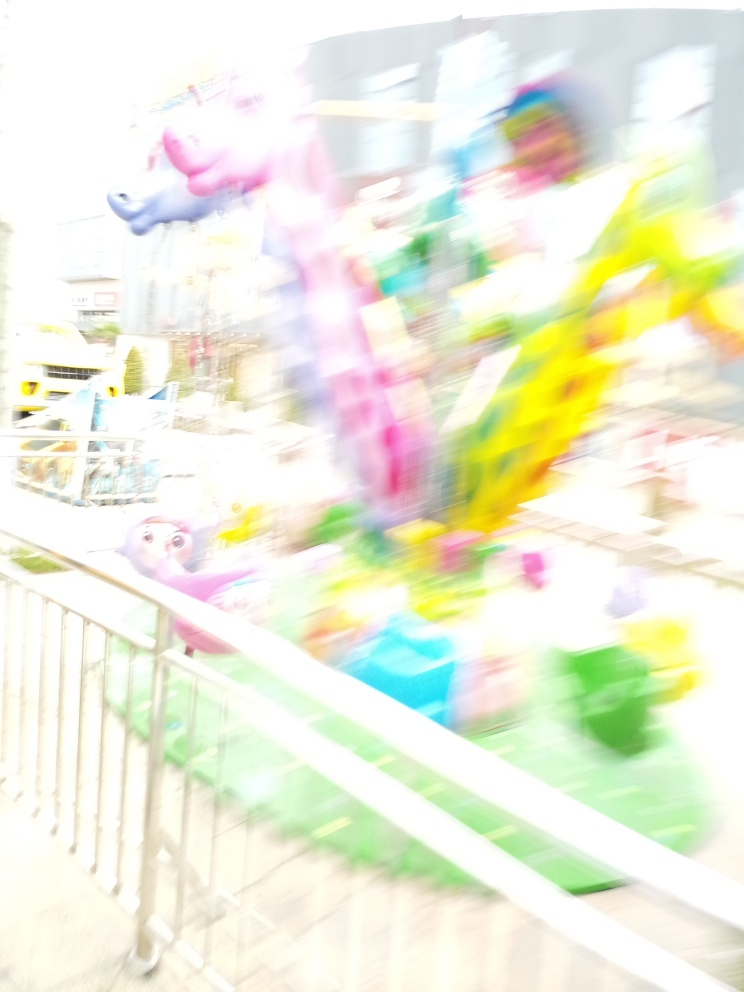What might have caused the blurriness in this photograph? The blurriness in the photograph is likely caused by camera movement during a long exposure time, or it may be intentional motion blur to convey a sense of action or movement in the scene, capturing the bustling atmosphere of the location. 